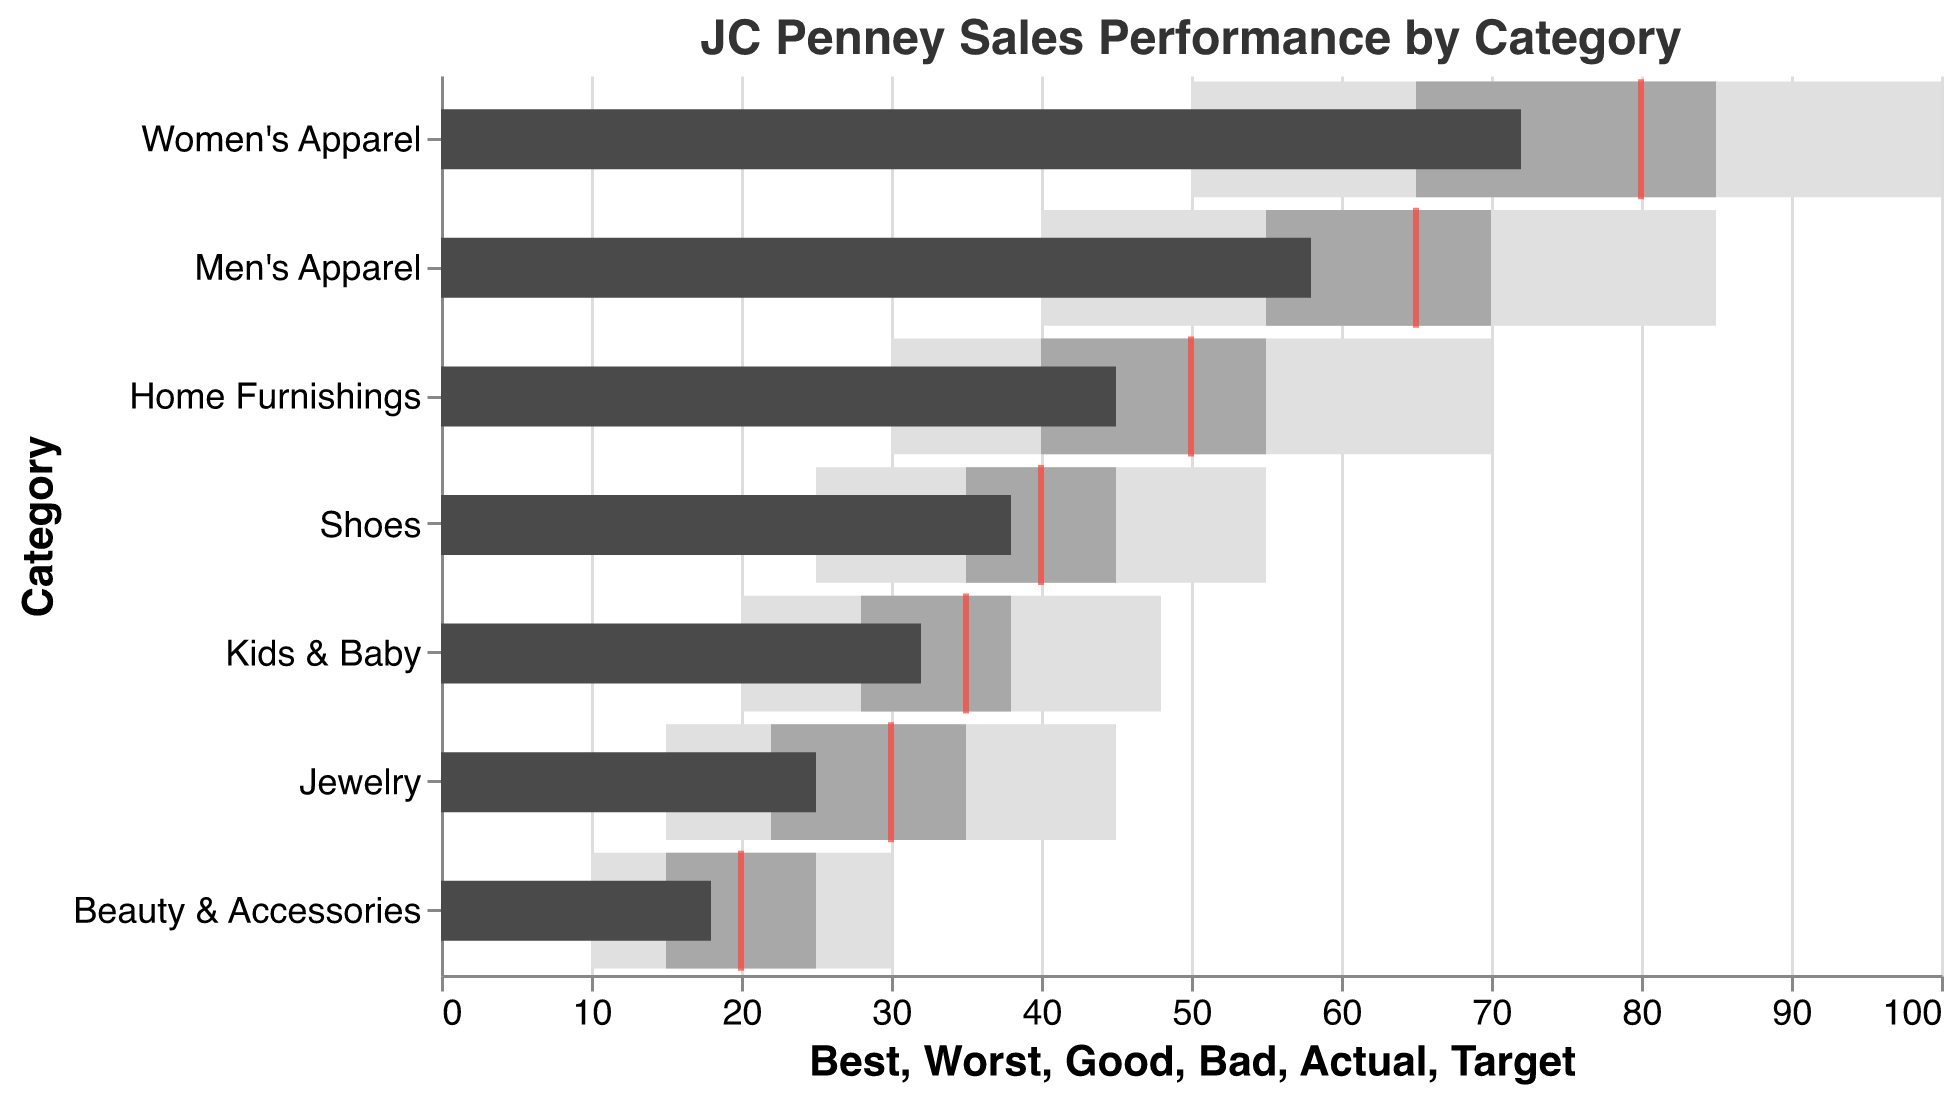What is the title of the figure? The title of the figure is generally positioned at the top and describes what the chart is about. By looking at the top of the chart, the title is clearly visible.
Answer: JC Penney Sales Performance by Category Which product category has the lowest target sales? By examining the red tick marks on the bar representing the target sales for each category, we can identify the lowest target value. The smallest red tick mark is next to Beauty & Accessories.
Answer: Beauty & Accessories What is the actual sales number for Men's Apparel? The actual sales are represented by dark bars. By looking at the dark bar adjacent to the Men's Apparel category, we can find its length, which corresponds to a value of 58.
Answer: 58 How many product categories have actual sales below their target? Compare each category's dark bar (actual) with its respective red tick mark (target). Counting those where the dark bar is shorter, we get Women's Apparel, Men's Apparel, Home Furnishings, Shoes, Jewelry, Kids & Baby, and Beauty & Accessories.
Answer: 7 What is the difference between the actual sales and the target sales for Shoes? The actual sales for Shoes is 38, and the target is 40. Subtracting actual from the target gives 40 - 38.
Answer: 2 Which product category is closest to meeting its sales target? To find the closest, look for the smallest gap between the actual (dark bar) and target (red tick). Shoes have the smallest gap of 2 units (40 target, 38 actual).
Answer: Shoes Which category has the highest actual sales? By scanning the lengths of the dark bars, the longest is next to Women's Apparel, indicating the highest actual sales.
Answer: Women's Apparel Are there any categories where actual sales exceeded the 'Bad' threshold but did not meet the 'Good' threshold? Checking each category, we compare the actual sales (dark bar) with the 'Bad' and 'Good' regions (different colored sections): Women’s Apparel, Men's Apparel, Home Furnishings, Shoes, Kids & Baby, and Beauty & Accessories fit this criterion.
Answer: 6 What range of sales is considered 'Good' for Home Furnishings? The 'Good' range values are represented by gray sections. For Home Furnishings, these sections fall between 40 and 55.
Answer: 40 to 55 